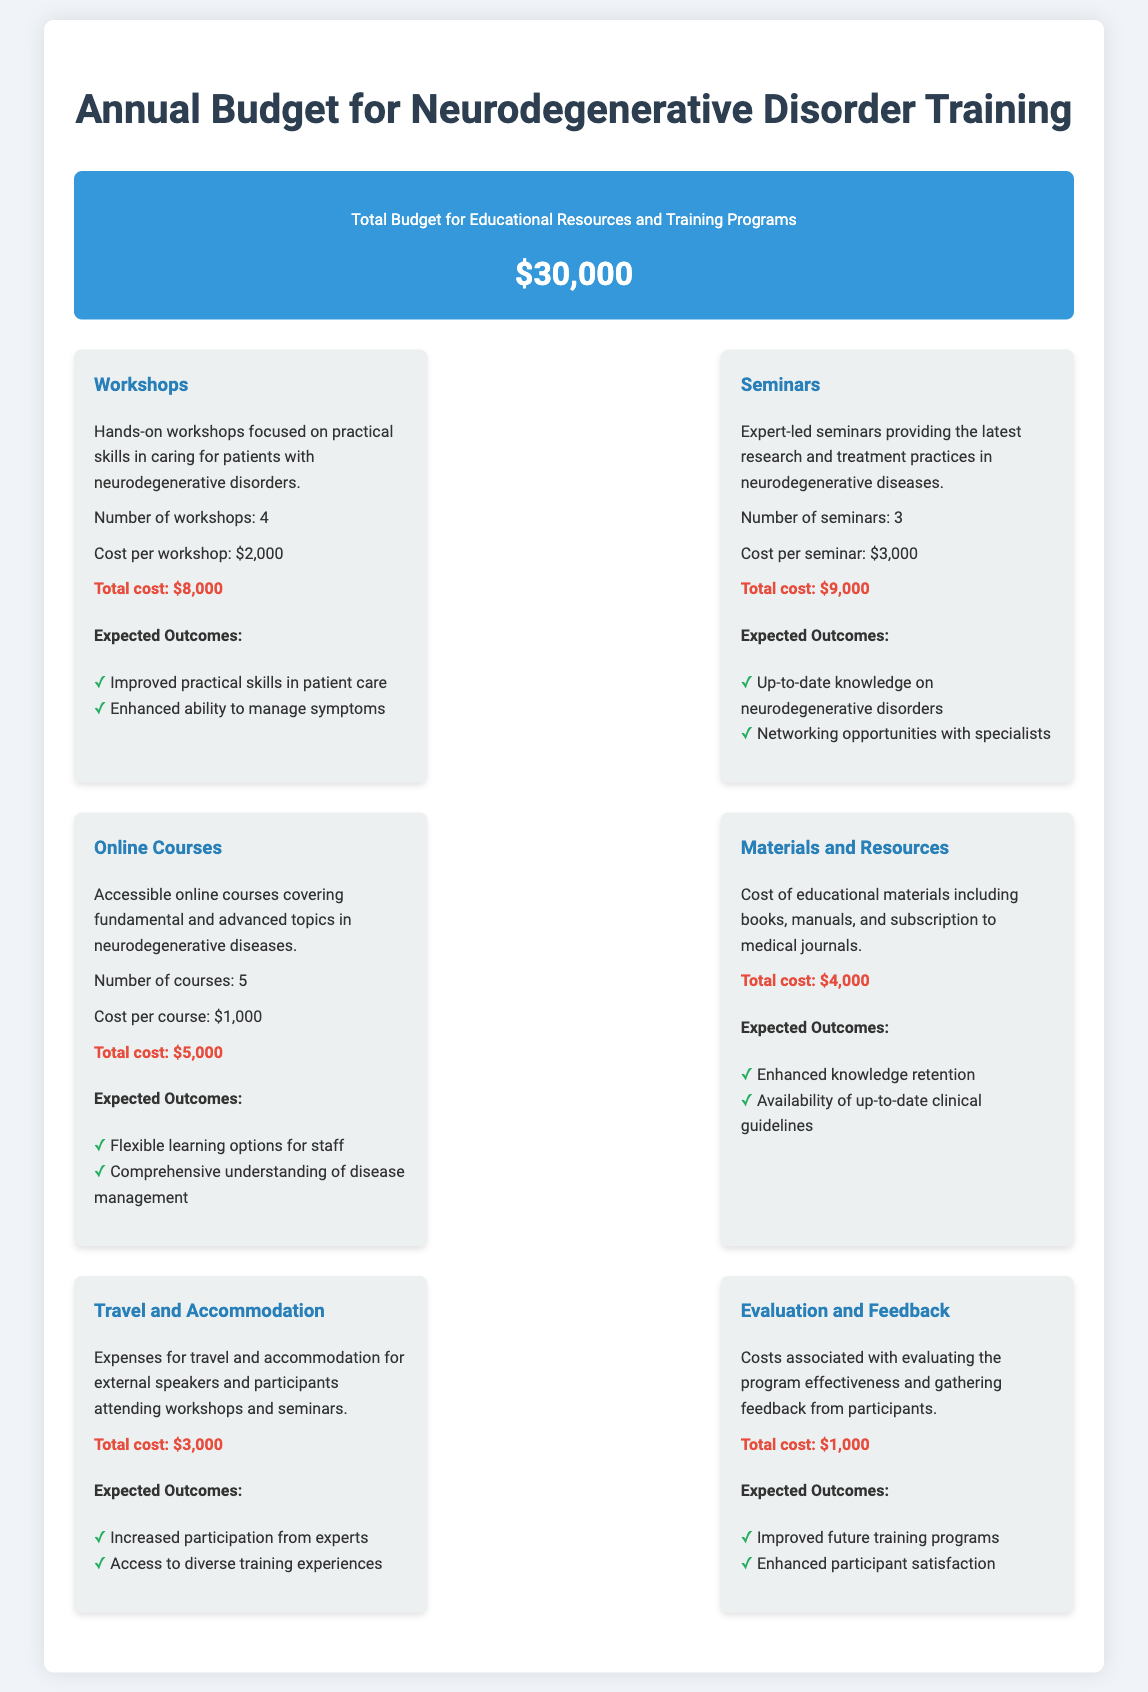What is the total budget for educational resources and training programs? The total budget is stated at the top of the document.
Answer: $30,000 How many workshops are planned? The number of workshops is mentioned in the budget item for workshops.
Answer: 4 What is the cost per seminar? The document specifies the cost per seminar in the seminars section.
Answer: $3,000 What is the total cost for online courses? The total cost for online courses is detailed in the online courses budget item.
Answer: $5,000 What are the expected outcomes for travel and accommodation? The expected outcomes for travel and accommodation can be found in the respective budget item.
Answer: Increased participation from experts, Access to diverse training experiences What is the total cost allocated for materials and resources? The total cost for materials and resources is listed in its dedicated section.
Answer: $4,000 How many seminars will be conducted? The number of seminars is explicitly given in the seminars section of the budget.
Answer: 3 What is the budget for evaluation and feedback? The cost for evaluation and feedback is specified in its own budget item.
Answer: $1,000 What is the total cost for workshops? The total cost for workshops is calculated and presented in the workshops budget item.
Answer: $8,000 